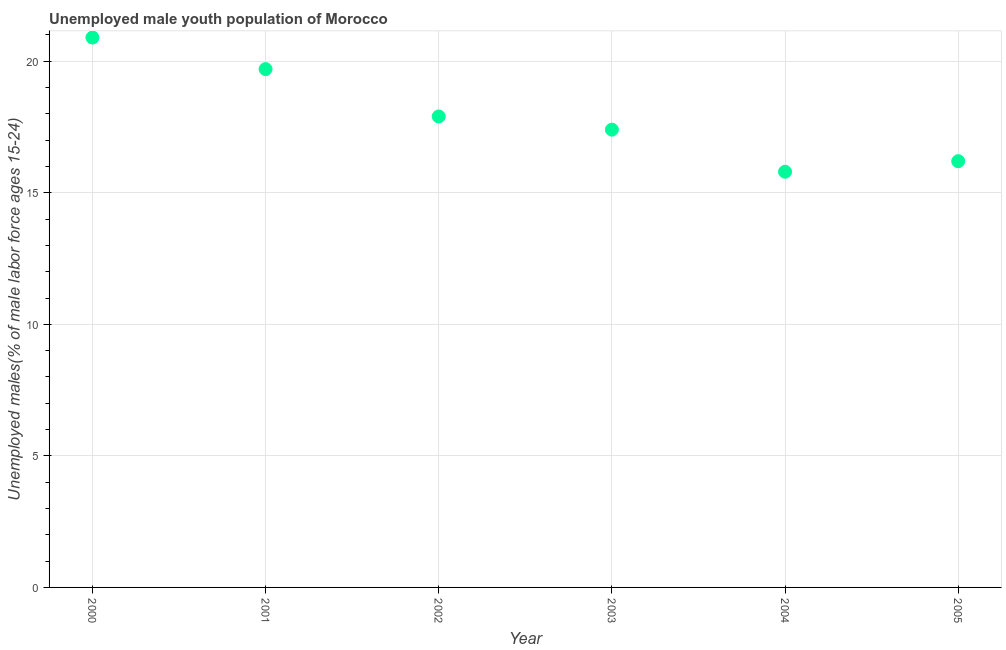What is the unemployed male youth in 2001?
Provide a short and direct response. 19.7. Across all years, what is the maximum unemployed male youth?
Your response must be concise. 20.9. Across all years, what is the minimum unemployed male youth?
Keep it short and to the point. 15.8. What is the sum of the unemployed male youth?
Offer a very short reply. 107.9. What is the difference between the unemployed male youth in 2000 and 2002?
Give a very brief answer. 3. What is the average unemployed male youth per year?
Keep it short and to the point. 17.98. What is the median unemployed male youth?
Your answer should be very brief. 17.65. Do a majority of the years between 2005 and 2000 (inclusive) have unemployed male youth greater than 13 %?
Your response must be concise. Yes. What is the ratio of the unemployed male youth in 2004 to that in 2005?
Your answer should be compact. 0.98. Is the unemployed male youth in 2001 less than that in 2004?
Provide a short and direct response. No. Is the difference between the unemployed male youth in 2003 and 2005 greater than the difference between any two years?
Your answer should be very brief. No. What is the difference between the highest and the second highest unemployed male youth?
Keep it short and to the point. 1.2. What is the difference between the highest and the lowest unemployed male youth?
Offer a terse response. 5.1. In how many years, is the unemployed male youth greater than the average unemployed male youth taken over all years?
Your answer should be very brief. 2. How many dotlines are there?
Ensure brevity in your answer.  1. How many years are there in the graph?
Keep it short and to the point. 6. Does the graph contain grids?
Make the answer very short. Yes. What is the title of the graph?
Ensure brevity in your answer.  Unemployed male youth population of Morocco. What is the label or title of the X-axis?
Ensure brevity in your answer.  Year. What is the label or title of the Y-axis?
Provide a short and direct response. Unemployed males(% of male labor force ages 15-24). What is the Unemployed males(% of male labor force ages 15-24) in 2000?
Make the answer very short. 20.9. What is the Unemployed males(% of male labor force ages 15-24) in 2001?
Keep it short and to the point. 19.7. What is the Unemployed males(% of male labor force ages 15-24) in 2002?
Give a very brief answer. 17.9. What is the Unemployed males(% of male labor force ages 15-24) in 2003?
Offer a terse response. 17.4. What is the Unemployed males(% of male labor force ages 15-24) in 2004?
Offer a very short reply. 15.8. What is the Unemployed males(% of male labor force ages 15-24) in 2005?
Provide a short and direct response. 16.2. What is the difference between the Unemployed males(% of male labor force ages 15-24) in 2000 and 2001?
Offer a terse response. 1.2. What is the difference between the Unemployed males(% of male labor force ages 15-24) in 2000 and 2002?
Provide a short and direct response. 3. What is the difference between the Unemployed males(% of male labor force ages 15-24) in 2000 and 2004?
Your answer should be very brief. 5.1. What is the difference between the Unemployed males(% of male labor force ages 15-24) in 2001 and 2002?
Your response must be concise. 1.8. What is the difference between the Unemployed males(% of male labor force ages 15-24) in 2002 and 2004?
Provide a short and direct response. 2.1. What is the difference between the Unemployed males(% of male labor force ages 15-24) in 2003 and 2004?
Make the answer very short. 1.6. What is the ratio of the Unemployed males(% of male labor force ages 15-24) in 2000 to that in 2001?
Provide a succinct answer. 1.06. What is the ratio of the Unemployed males(% of male labor force ages 15-24) in 2000 to that in 2002?
Your answer should be very brief. 1.17. What is the ratio of the Unemployed males(% of male labor force ages 15-24) in 2000 to that in 2003?
Keep it short and to the point. 1.2. What is the ratio of the Unemployed males(% of male labor force ages 15-24) in 2000 to that in 2004?
Your answer should be compact. 1.32. What is the ratio of the Unemployed males(% of male labor force ages 15-24) in 2000 to that in 2005?
Provide a short and direct response. 1.29. What is the ratio of the Unemployed males(% of male labor force ages 15-24) in 2001 to that in 2002?
Provide a succinct answer. 1.1. What is the ratio of the Unemployed males(% of male labor force ages 15-24) in 2001 to that in 2003?
Your response must be concise. 1.13. What is the ratio of the Unemployed males(% of male labor force ages 15-24) in 2001 to that in 2004?
Provide a succinct answer. 1.25. What is the ratio of the Unemployed males(% of male labor force ages 15-24) in 2001 to that in 2005?
Provide a succinct answer. 1.22. What is the ratio of the Unemployed males(% of male labor force ages 15-24) in 2002 to that in 2004?
Provide a succinct answer. 1.13. What is the ratio of the Unemployed males(% of male labor force ages 15-24) in 2002 to that in 2005?
Your answer should be very brief. 1.1. What is the ratio of the Unemployed males(% of male labor force ages 15-24) in 2003 to that in 2004?
Your answer should be very brief. 1.1. What is the ratio of the Unemployed males(% of male labor force ages 15-24) in 2003 to that in 2005?
Keep it short and to the point. 1.07. What is the ratio of the Unemployed males(% of male labor force ages 15-24) in 2004 to that in 2005?
Provide a succinct answer. 0.97. 